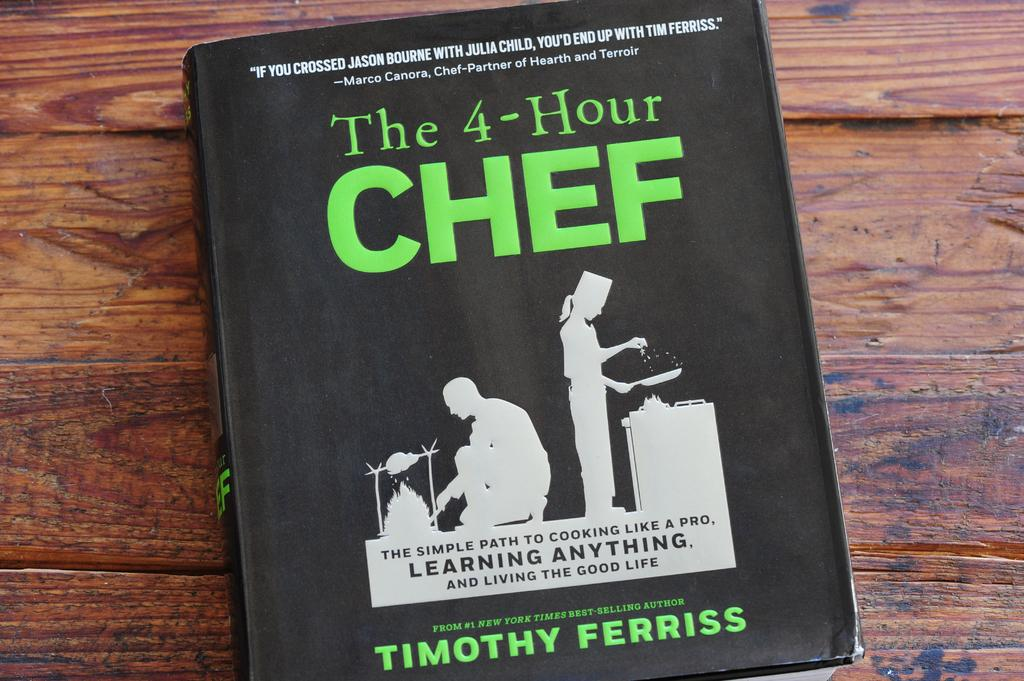<image>
Render a clear and concise summary of the photo. A book called the 4 hour chef that is written by Timothy Ferriss about learning anything. 